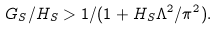<formula> <loc_0><loc_0><loc_500><loc_500>G _ { S } / H _ { S } > 1 / ( 1 + H _ { S } \Lambda ^ { 2 } / \pi ^ { 2 } ) .</formula> 